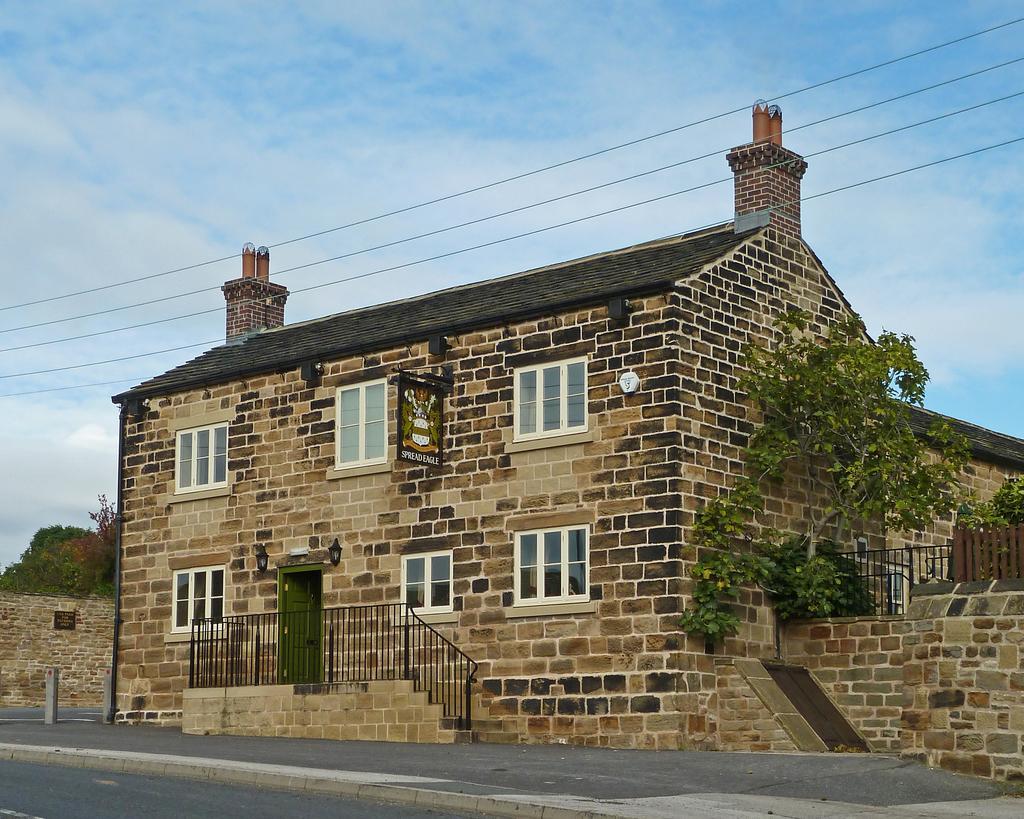Please provide a concise description of this image. In this image we can see road, buildings, windows, doors, trees, electric wires, railings, fence and clouds in the sky. 